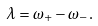Convert formula to latex. <formula><loc_0><loc_0><loc_500><loc_500>\lambda = \omega _ { + } - \omega _ { - } .</formula> 